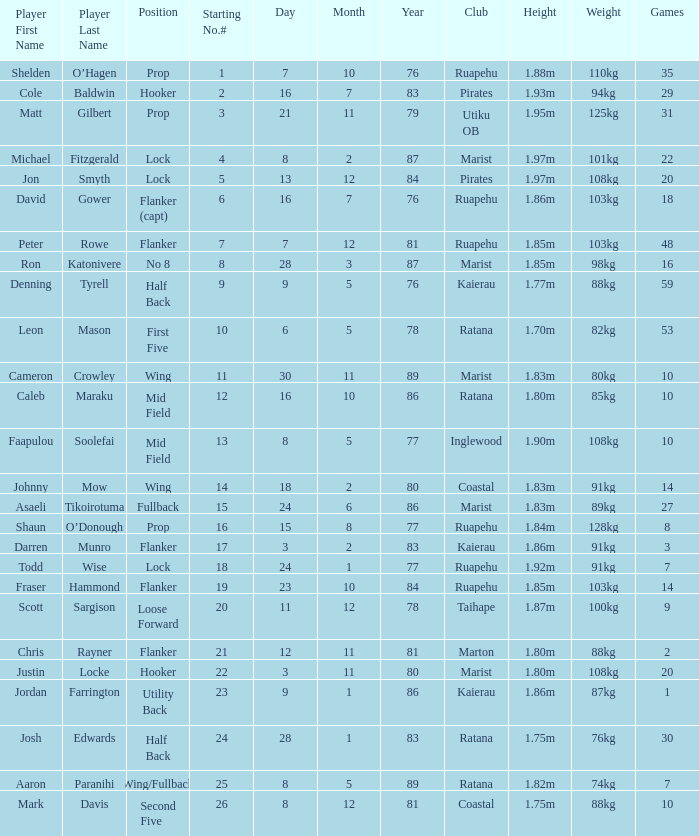Which participant weighs 76kg? Josh Edwards. 